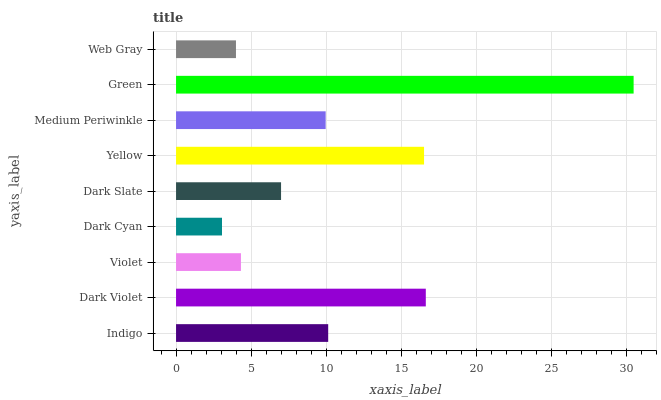Is Dark Cyan the minimum?
Answer yes or no. Yes. Is Green the maximum?
Answer yes or no. Yes. Is Dark Violet the minimum?
Answer yes or no. No. Is Dark Violet the maximum?
Answer yes or no. No. Is Dark Violet greater than Indigo?
Answer yes or no. Yes. Is Indigo less than Dark Violet?
Answer yes or no. Yes. Is Indigo greater than Dark Violet?
Answer yes or no. No. Is Dark Violet less than Indigo?
Answer yes or no. No. Is Medium Periwinkle the high median?
Answer yes or no. Yes. Is Medium Periwinkle the low median?
Answer yes or no. Yes. Is Yellow the high median?
Answer yes or no. No. Is Violet the low median?
Answer yes or no. No. 